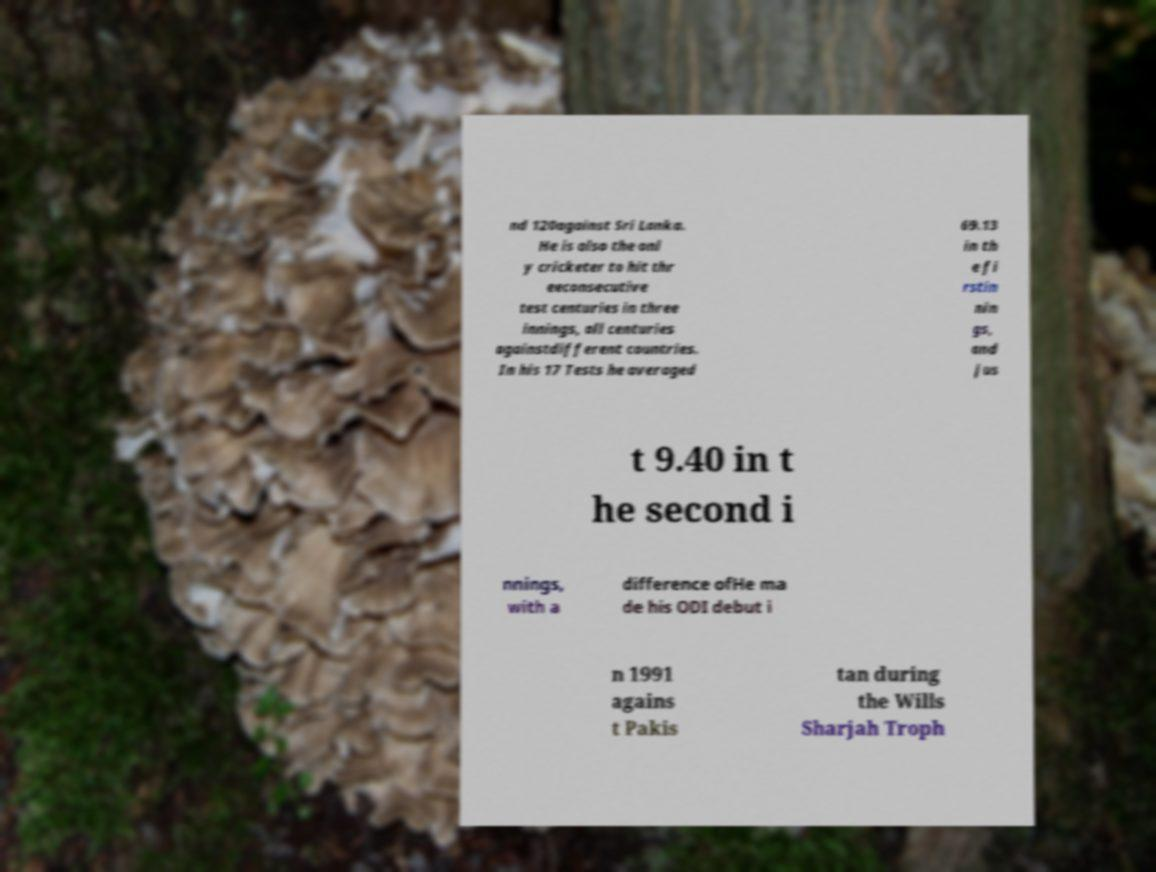Can you suggest a creative narrative that could explain why this message is placed in this particular backdrop? One imaginative scenario could be that this message is part of an environmental awareness campaign. The text juxtaposed against the natural fungi backdrop might emphasize the ties between sports, nature, and international collaboration, urging viewers to consider the interconnectedness of global systems.  How might this image be used to inspire people about environmental conservation? This image could be used to inspire environmental conservation by highlighting the beauty and intricacy of natural phenomena like fungi, which are often overlooked. It can serve as a reminder of the delicate balance of ecosystems and our role in protecting and preserving them for future generations. 